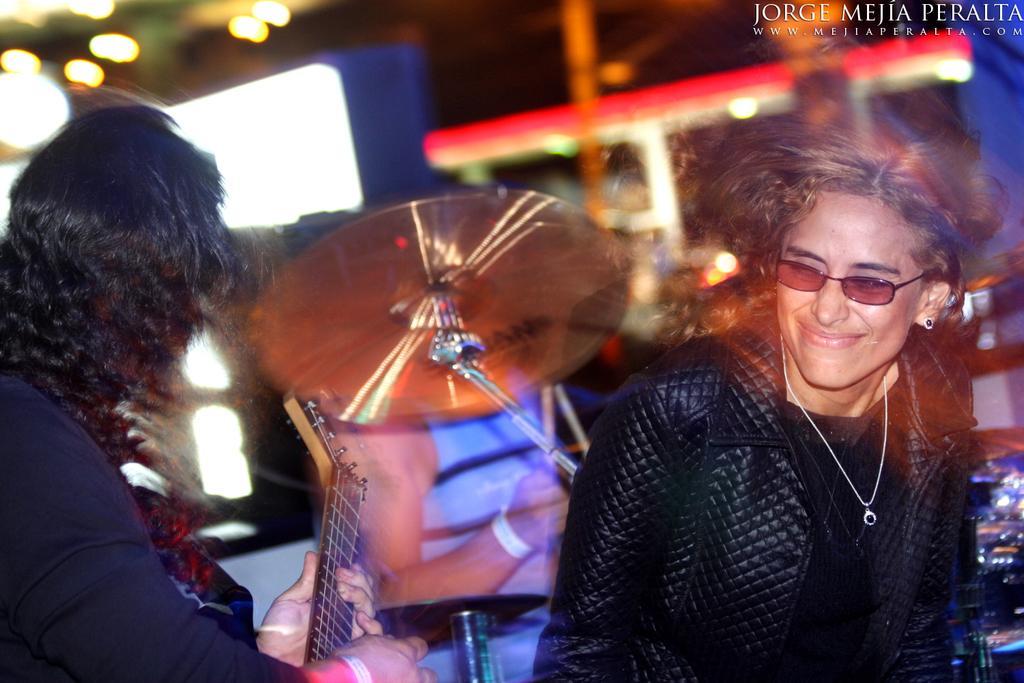How would you summarize this image in a sentence or two? Here we can see a group of people, the guy on the left side is playing a guitar and at center he is playing drums and at the right side the person is laughing 